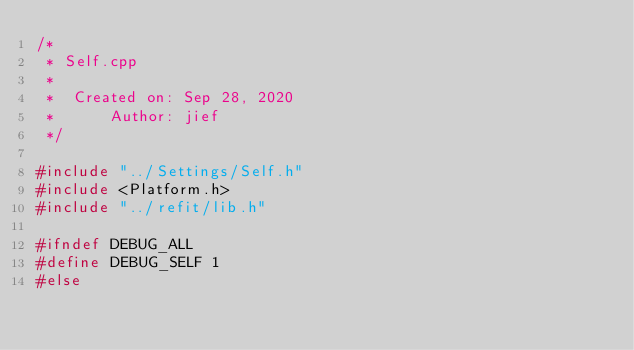<code> <loc_0><loc_0><loc_500><loc_500><_C++_>/*
 * Self.cpp
 *
 *  Created on: Sep 28, 2020
 *      Author: jief
 */

#include "../Settings/Self.h"
#include <Platform.h>
#include "../refit/lib.h"

#ifndef DEBUG_ALL
#define DEBUG_SELF 1
#else</code> 